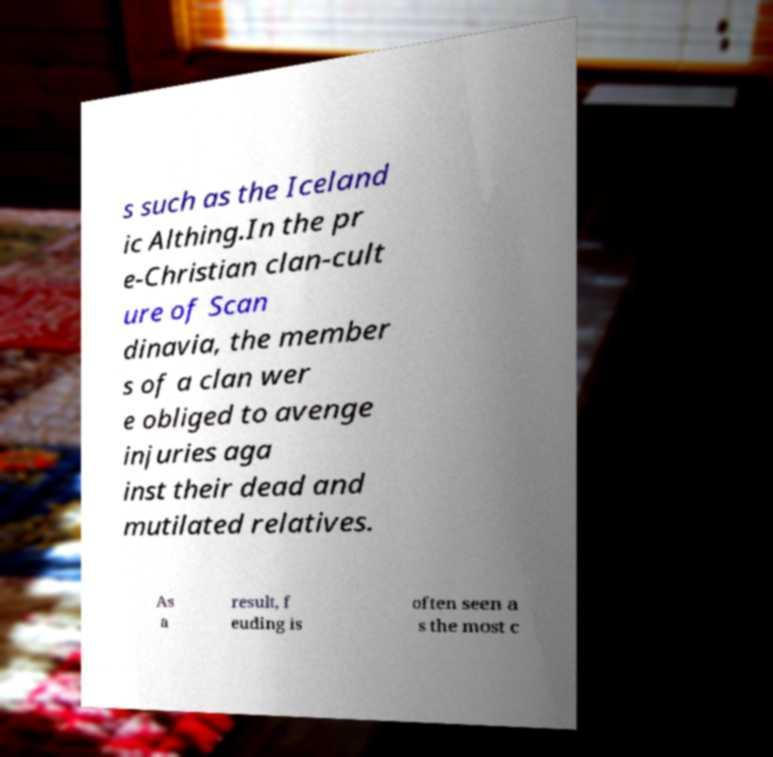There's text embedded in this image that I need extracted. Can you transcribe it verbatim? s such as the Iceland ic Althing.In the pr e-Christian clan-cult ure of Scan dinavia, the member s of a clan wer e obliged to avenge injuries aga inst their dead and mutilated relatives. As a result, f euding is often seen a s the most c 